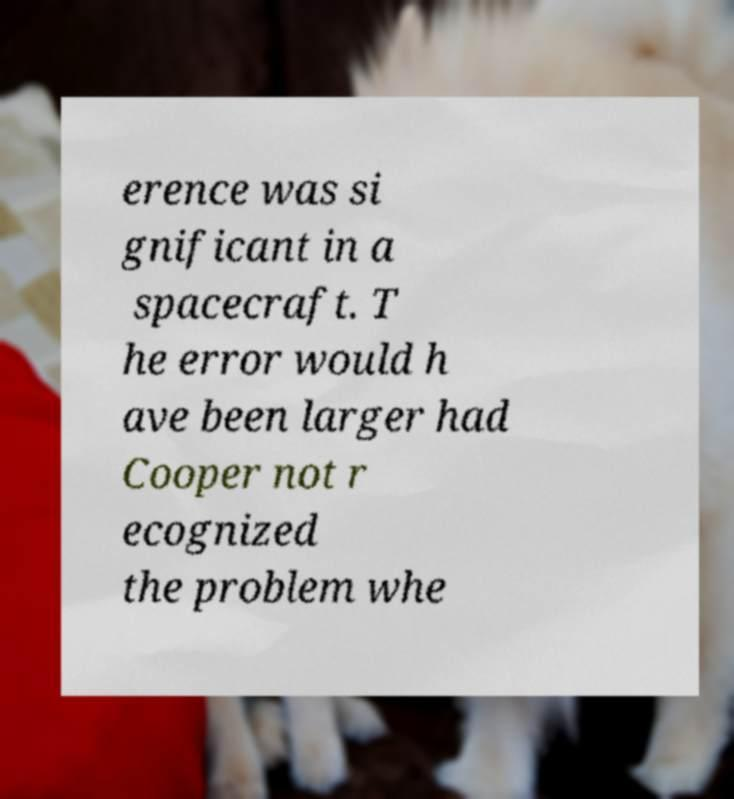Could you assist in decoding the text presented in this image and type it out clearly? erence was si gnificant in a spacecraft. T he error would h ave been larger had Cooper not r ecognized the problem whe 